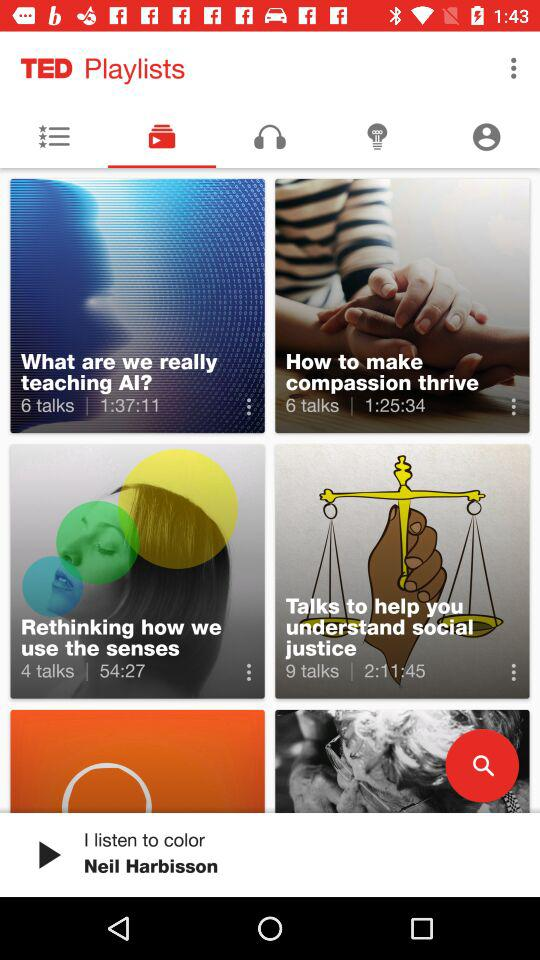What is the application name? The application name is "TED". 